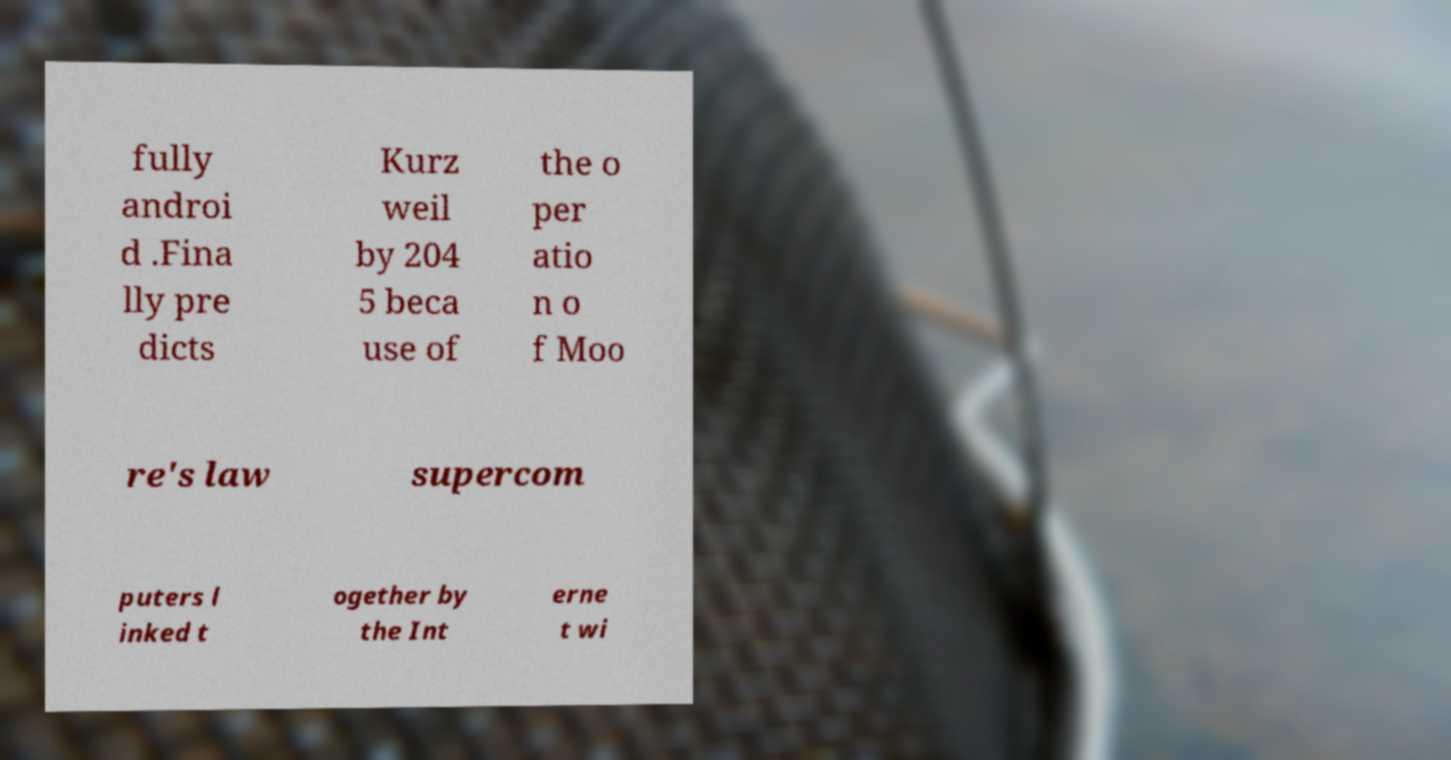Can you accurately transcribe the text from the provided image for me? fully androi d .Fina lly pre dicts Kurz weil by 204 5 beca use of the o per atio n o f Moo re's law supercom puters l inked t ogether by the Int erne t wi 